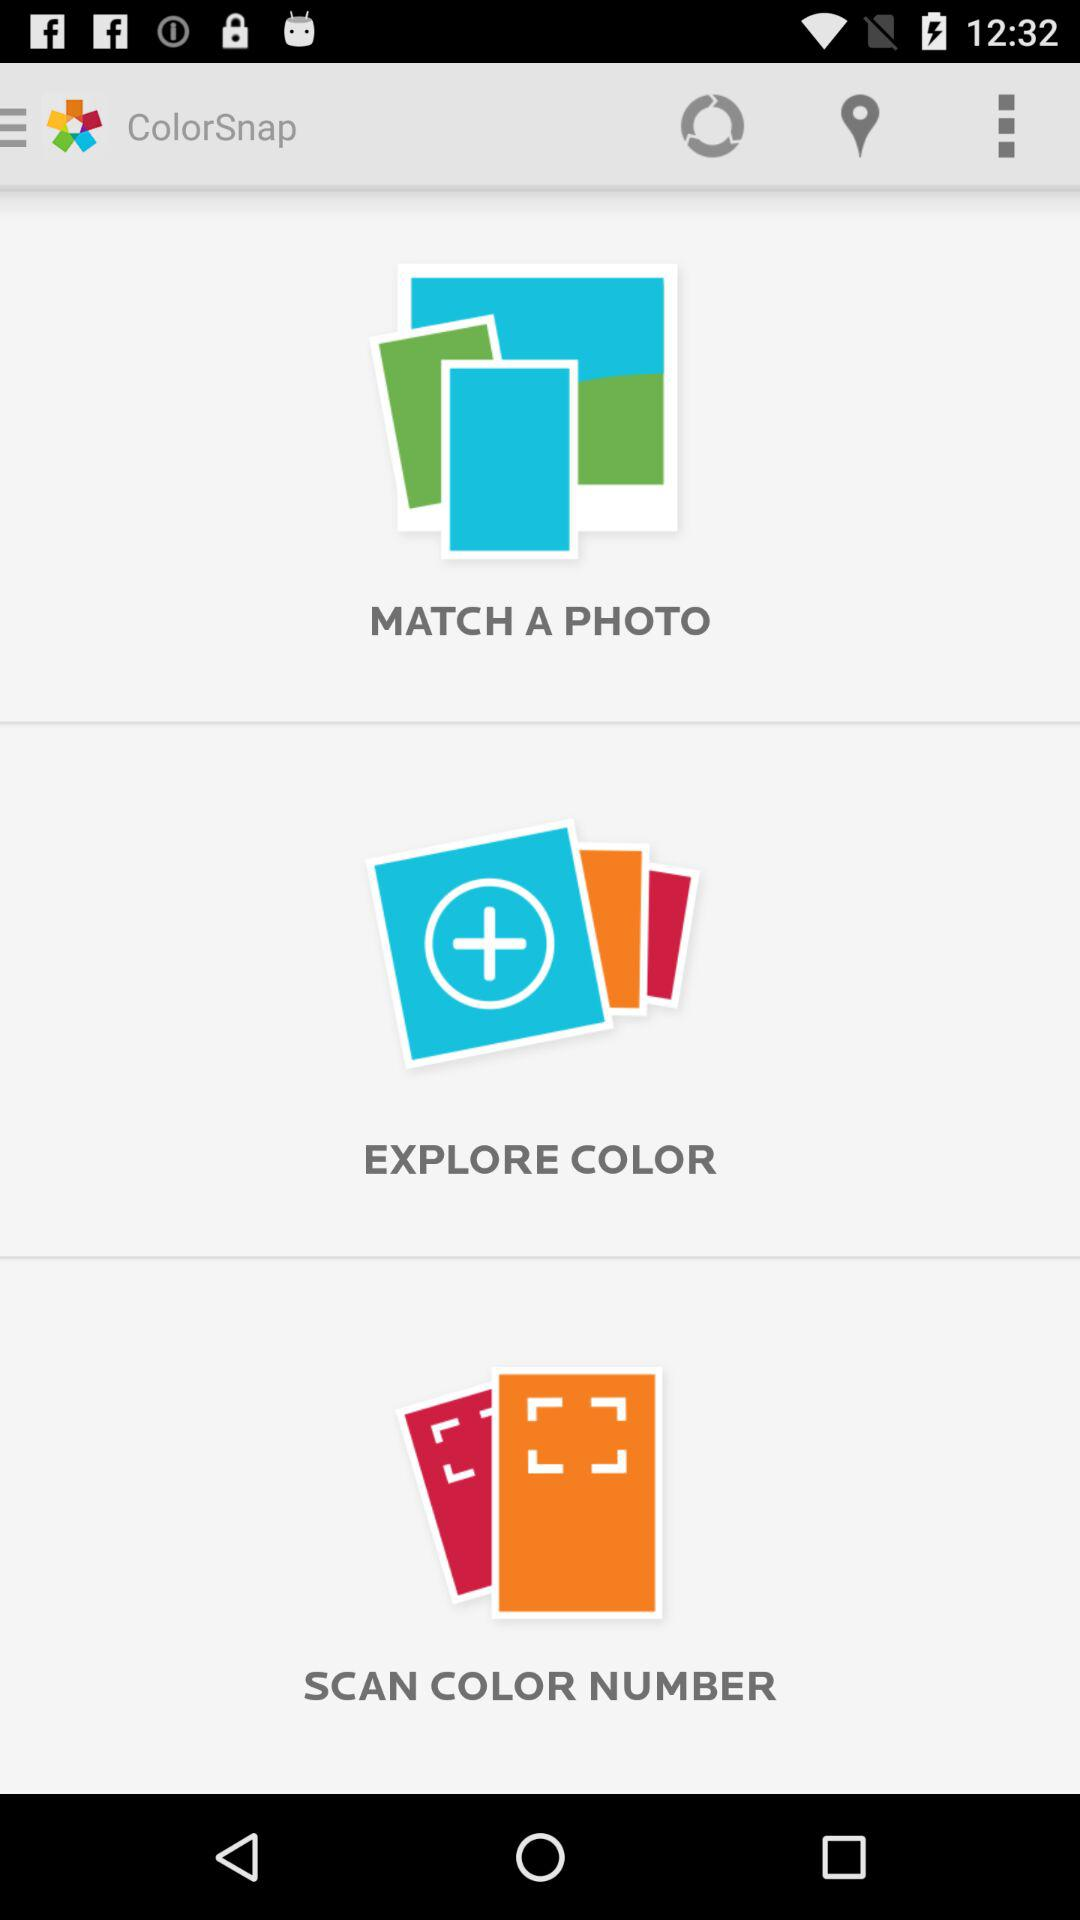What is the application name? The application name is "ColorSnap". 